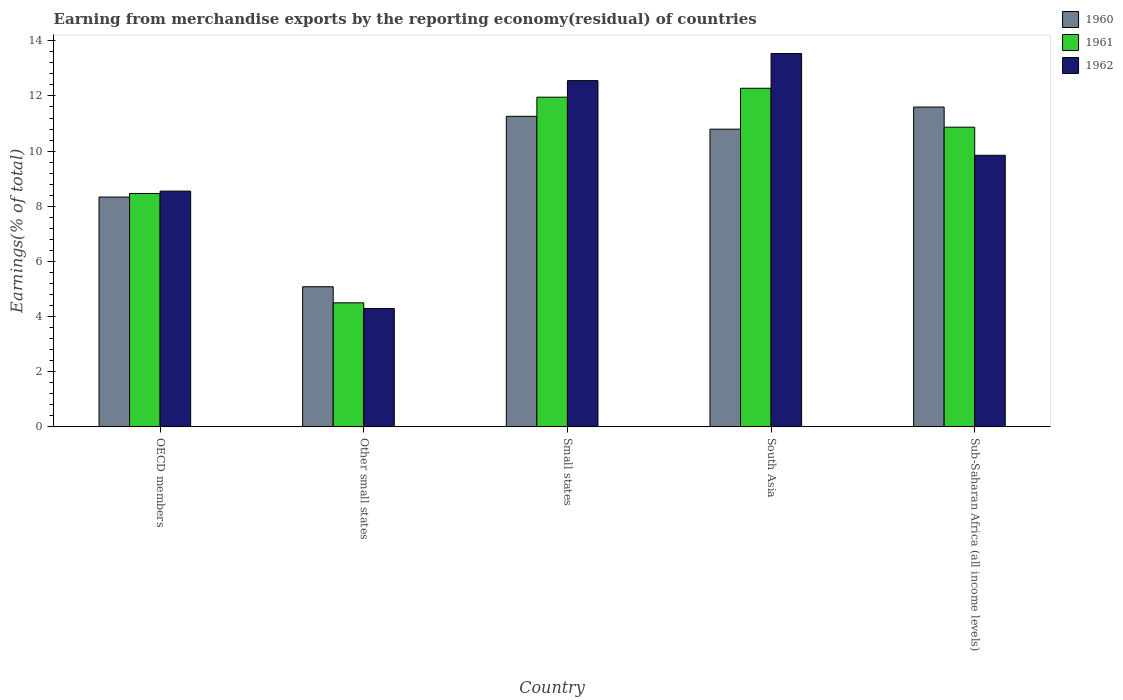How many different coloured bars are there?
Provide a short and direct response. 3. How many groups of bars are there?
Ensure brevity in your answer.  5. How many bars are there on the 3rd tick from the left?
Provide a short and direct response. 3. What is the label of the 2nd group of bars from the left?
Provide a succinct answer. Other small states. In how many cases, is the number of bars for a given country not equal to the number of legend labels?
Offer a terse response. 0. What is the percentage of amount earned from merchandise exports in 1962 in Other small states?
Your answer should be compact. 4.29. Across all countries, what is the maximum percentage of amount earned from merchandise exports in 1961?
Ensure brevity in your answer.  12.28. Across all countries, what is the minimum percentage of amount earned from merchandise exports in 1962?
Give a very brief answer. 4.29. In which country was the percentage of amount earned from merchandise exports in 1960 minimum?
Your response must be concise. Other small states. What is the total percentage of amount earned from merchandise exports in 1961 in the graph?
Offer a very short reply. 48.06. What is the difference between the percentage of amount earned from merchandise exports in 1960 in OECD members and that in Other small states?
Ensure brevity in your answer.  3.25. What is the difference between the percentage of amount earned from merchandise exports in 1960 in Small states and the percentage of amount earned from merchandise exports in 1961 in Other small states?
Offer a terse response. 6.76. What is the average percentage of amount earned from merchandise exports in 1962 per country?
Ensure brevity in your answer.  9.76. What is the difference between the percentage of amount earned from merchandise exports of/in 1960 and percentage of amount earned from merchandise exports of/in 1961 in Sub-Saharan Africa (all income levels)?
Give a very brief answer. 0.73. What is the ratio of the percentage of amount earned from merchandise exports in 1960 in Small states to that in South Asia?
Make the answer very short. 1.04. What is the difference between the highest and the second highest percentage of amount earned from merchandise exports in 1960?
Offer a very short reply. 0.47. What is the difference between the highest and the lowest percentage of amount earned from merchandise exports in 1960?
Your response must be concise. 6.52. Is the sum of the percentage of amount earned from merchandise exports in 1962 in OECD members and Other small states greater than the maximum percentage of amount earned from merchandise exports in 1961 across all countries?
Provide a short and direct response. Yes. What does the 3rd bar from the right in Other small states represents?
Your answer should be very brief. 1960. How many countries are there in the graph?
Provide a short and direct response. 5. How many legend labels are there?
Offer a very short reply. 3. What is the title of the graph?
Your response must be concise. Earning from merchandise exports by the reporting economy(residual) of countries. Does "1991" appear as one of the legend labels in the graph?
Offer a terse response. No. What is the label or title of the X-axis?
Your response must be concise. Country. What is the label or title of the Y-axis?
Provide a short and direct response. Earnings(% of total). What is the Earnings(% of total) of 1960 in OECD members?
Ensure brevity in your answer.  8.33. What is the Earnings(% of total) of 1961 in OECD members?
Your response must be concise. 8.46. What is the Earnings(% of total) of 1962 in OECD members?
Make the answer very short. 8.55. What is the Earnings(% of total) in 1960 in Other small states?
Offer a very short reply. 5.08. What is the Earnings(% of total) in 1961 in Other small states?
Provide a short and direct response. 4.5. What is the Earnings(% of total) in 1962 in Other small states?
Give a very brief answer. 4.29. What is the Earnings(% of total) in 1960 in Small states?
Make the answer very short. 11.26. What is the Earnings(% of total) of 1961 in Small states?
Ensure brevity in your answer.  11.96. What is the Earnings(% of total) in 1962 in Small states?
Provide a short and direct response. 12.56. What is the Earnings(% of total) of 1960 in South Asia?
Provide a succinct answer. 10.8. What is the Earnings(% of total) of 1961 in South Asia?
Ensure brevity in your answer.  12.28. What is the Earnings(% of total) in 1962 in South Asia?
Give a very brief answer. 13.54. What is the Earnings(% of total) of 1960 in Sub-Saharan Africa (all income levels)?
Give a very brief answer. 11.6. What is the Earnings(% of total) in 1961 in Sub-Saharan Africa (all income levels)?
Offer a very short reply. 10.87. What is the Earnings(% of total) in 1962 in Sub-Saharan Africa (all income levels)?
Provide a succinct answer. 9.85. Across all countries, what is the maximum Earnings(% of total) of 1960?
Ensure brevity in your answer.  11.6. Across all countries, what is the maximum Earnings(% of total) in 1961?
Give a very brief answer. 12.28. Across all countries, what is the maximum Earnings(% of total) of 1962?
Provide a short and direct response. 13.54. Across all countries, what is the minimum Earnings(% of total) in 1960?
Give a very brief answer. 5.08. Across all countries, what is the minimum Earnings(% of total) of 1961?
Give a very brief answer. 4.5. Across all countries, what is the minimum Earnings(% of total) of 1962?
Make the answer very short. 4.29. What is the total Earnings(% of total) in 1960 in the graph?
Your answer should be compact. 47.07. What is the total Earnings(% of total) in 1961 in the graph?
Offer a very short reply. 48.06. What is the total Earnings(% of total) in 1962 in the graph?
Offer a terse response. 48.78. What is the difference between the Earnings(% of total) of 1960 in OECD members and that in Other small states?
Offer a very short reply. 3.25. What is the difference between the Earnings(% of total) in 1961 in OECD members and that in Other small states?
Make the answer very short. 3.96. What is the difference between the Earnings(% of total) in 1962 in OECD members and that in Other small states?
Provide a short and direct response. 4.26. What is the difference between the Earnings(% of total) of 1960 in OECD members and that in Small states?
Your response must be concise. -2.93. What is the difference between the Earnings(% of total) in 1961 in OECD members and that in Small states?
Give a very brief answer. -3.49. What is the difference between the Earnings(% of total) in 1962 in OECD members and that in Small states?
Your response must be concise. -4.01. What is the difference between the Earnings(% of total) of 1960 in OECD members and that in South Asia?
Keep it short and to the point. -2.46. What is the difference between the Earnings(% of total) of 1961 in OECD members and that in South Asia?
Provide a succinct answer. -3.82. What is the difference between the Earnings(% of total) in 1962 in OECD members and that in South Asia?
Your answer should be very brief. -4.99. What is the difference between the Earnings(% of total) of 1960 in OECD members and that in Sub-Saharan Africa (all income levels)?
Your answer should be very brief. -3.26. What is the difference between the Earnings(% of total) in 1961 in OECD members and that in Sub-Saharan Africa (all income levels)?
Ensure brevity in your answer.  -2.4. What is the difference between the Earnings(% of total) of 1962 in OECD members and that in Sub-Saharan Africa (all income levels)?
Provide a short and direct response. -1.3. What is the difference between the Earnings(% of total) of 1960 in Other small states and that in Small states?
Make the answer very short. -6.18. What is the difference between the Earnings(% of total) of 1961 in Other small states and that in Small states?
Your response must be concise. -7.46. What is the difference between the Earnings(% of total) in 1962 in Other small states and that in Small states?
Your answer should be very brief. -8.26. What is the difference between the Earnings(% of total) in 1960 in Other small states and that in South Asia?
Provide a short and direct response. -5.71. What is the difference between the Earnings(% of total) in 1961 in Other small states and that in South Asia?
Provide a succinct answer. -7.78. What is the difference between the Earnings(% of total) in 1962 in Other small states and that in South Asia?
Your response must be concise. -9.24. What is the difference between the Earnings(% of total) of 1960 in Other small states and that in Sub-Saharan Africa (all income levels)?
Your response must be concise. -6.52. What is the difference between the Earnings(% of total) of 1961 in Other small states and that in Sub-Saharan Africa (all income levels)?
Your response must be concise. -6.37. What is the difference between the Earnings(% of total) of 1962 in Other small states and that in Sub-Saharan Africa (all income levels)?
Offer a very short reply. -5.56. What is the difference between the Earnings(% of total) in 1960 in Small states and that in South Asia?
Offer a very short reply. 0.47. What is the difference between the Earnings(% of total) of 1961 in Small states and that in South Asia?
Keep it short and to the point. -0.32. What is the difference between the Earnings(% of total) of 1962 in Small states and that in South Asia?
Your answer should be compact. -0.98. What is the difference between the Earnings(% of total) of 1960 in Small states and that in Sub-Saharan Africa (all income levels)?
Provide a succinct answer. -0.34. What is the difference between the Earnings(% of total) of 1961 in Small states and that in Sub-Saharan Africa (all income levels)?
Your response must be concise. 1.09. What is the difference between the Earnings(% of total) of 1962 in Small states and that in Sub-Saharan Africa (all income levels)?
Offer a terse response. 2.71. What is the difference between the Earnings(% of total) of 1960 in South Asia and that in Sub-Saharan Africa (all income levels)?
Make the answer very short. -0.8. What is the difference between the Earnings(% of total) in 1961 in South Asia and that in Sub-Saharan Africa (all income levels)?
Offer a very short reply. 1.41. What is the difference between the Earnings(% of total) in 1962 in South Asia and that in Sub-Saharan Africa (all income levels)?
Provide a short and direct response. 3.69. What is the difference between the Earnings(% of total) of 1960 in OECD members and the Earnings(% of total) of 1961 in Other small states?
Offer a very short reply. 3.84. What is the difference between the Earnings(% of total) of 1960 in OECD members and the Earnings(% of total) of 1962 in Other small states?
Make the answer very short. 4.04. What is the difference between the Earnings(% of total) in 1961 in OECD members and the Earnings(% of total) in 1962 in Other small states?
Your answer should be compact. 4.17. What is the difference between the Earnings(% of total) of 1960 in OECD members and the Earnings(% of total) of 1961 in Small states?
Provide a short and direct response. -3.62. What is the difference between the Earnings(% of total) of 1960 in OECD members and the Earnings(% of total) of 1962 in Small states?
Ensure brevity in your answer.  -4.22. What is the difference between the Earnings(% of total) in 1961 in OECD members and the Earnings(% of total) in 1962 in Small states?
Keep it short and to the point. -4.09. What is the difference between the Earnings(% of total) of 1960 in OECD members and the Earnings(% of total) of 1961 in South Asia?
Give a very brief answer. -3.94. What is the difference between the Earnings(% of total) in 1960 in OECD members and the Earnings(% of total) in 1962 in South Asia?
Your response must be concise. -5.2. What is the difference between the Earnings(% of total) of 1961 in OECD members and the Earnings(% of total) of 1962 in South Asia?
Ensure brevity in your answer.  -5.07. What is the difference between the Earnings(% of total) in 1960 in OECD members and the Earnings(% of total) in 1961 in Sub-Saharan Africa (all income levels)?
Give a very brief answer. -2.53. What is the difference between the Earnings(% of total) in 1960 in OECD members and the Earnings(% of total) in 1962 in Sub-Saharan Africa (all income levels)?
Make the answer very short. -1.51. What is the difference between the Earnings(% of total) of 1961 in OECD members and the Earnings(% of total) of 1962 in Sub-Saharan Africa (all income levels)?
Provide a short and direct response. -1.39. What is the difference between the Earnings(% of total) in 1960 in Other small states and the Earnings(% of total) in 1961 in Small states?
Your response must be concise. -6.87. What is the difference between the Earnings(% of total) in 1960 in Other small states and the Earnings(% of total) in 1962 in Small states?
Provide a short and direct response. -7.47. What is the difference between the Earnings(% of total) in 1961 in Other small states and the Earnings(% of total) in 1962 in Small states?
Keep it short and to the point. -8.06. What is the difference between the Earnings(% of total) of 1960 in Other small states and the Earnings(% of total) of 1961 in South Asia?
Offer a terse response. -7.2. What is the difference between the Earnings(% of total) of 1960 in Other small states and the Earnings(% of total) of 1962 in South Asia?
Provide a short and direct response. -8.46. What is the difference between the Earnings(% of total) in 1961 in Other small states and the Earnings(% of total) in 1962 in South Asia?
Your answer should be compact. -9.04. What is the difference between the Earnings(% of total) of 1960 in Other small states and the Earnings(% of total) of 1961 in Sub-Saharan Africa (all income levels)?
Offer a very short reply. -5.79. What is the difference between the Earnings(% of total) in 1960 in Other small states and the Earnings(% of total) in 1962 in Sub-Saharan Africa (all income levels)?
Keep it short and to the point. -4.77. What is the difference between the Earnings(% of total) of 1961 in Other small states and the Earnings(% of total) of 1962 in Sub-Saharan Africa (all income levels)?
Your response must be concise. -5.35. What is the difference between the Earnings(% of total) of 1960 in Small states and the Earnings(% of total) of 1961 in South Asia?
Your answer should be compact. -1.02. What is the difference between the Earnings(% of total) of 1960 in Small states and the Earnings(% of total) of 1962 in South Asia?
Your answer should be compact. -2.28. What is the difference between the Earnings(% of total) of 1961 in Small states and the Earnings(% of total) of 1962 in South Asia?
Keep it short and to the point. -1.58. What is the difference between the Earnings(% of total) of 1960 in Small states and the Earnings(% of total) of 1961 in Sub-Saharan Africa (all income levels)?
Offer a very short reply. 0.39. What is the difference between the Earnings(% of total) in 1960 in Small states and the Earnings(% of total) in 1962 in Sub-Saharan Africa (all income levels)?
Make the answer very short. 1.41. What is the difference between the Earnings(% of total) in 1961 in Small states and the Earnings(% of total) in 1962 in Sub-Saharan Africa (all income levels)?
Offer a very short reply. 2.11. What is the difference between the Earnings(% of total) in 1960 in South Asia and the Earnings(% of total) in 1961 in Sub-Saharan Africa (all income levels)?
Your response must be concise. -0.07. What is the difference between the Earnings(% of total) of 1960 in South Asia and the Earnings(% of total) of 1962 in Sub-Saharan Africa (all income levels)?
Offer a very short reply. 0.95. What is the difference between the Earnings(% of total) of 1961 in South Asia and the Earnings(% of total) of 1962 in Sub-Saharan Africa (all income levels)?
Keep it short and to the point. 2.43. What is the average Earnings(% of total) in 1960 per country?
Keep it short and to the point. 9.41. What is the average Earnings(% of total) in 1961 per country?
Your answer should be compact. 9.61. What is the average Earnings(% of total) in 1962 per country?
Provide a short and direct response. 9.76. What is the difference between the Earnings(% of total) of 1960 and Earnings(% of total) of 1961 in OECD members?
Your answer should be very brief. -0.13. What is the difference between the Earnings(% of total) in 1960 and Earnings(% of total) in 1962 in OECD members?
Provide a short and direct response. -0.21. What is the difference between the Earnings(% of total) in 1961 and Earnings(% of total) in 1962 in OECD members?
Keep it short and to the point. -0.09. What is the difference between the Earnings(% of total) of 1960 and Earnings(% of total) of 1961 in Other small states?
Make the answer very short. 0.58. What is the difference between the Earnings(% of total) of 1960 and Earnings(% of total) of 1962 in Other small states?
Your answer should be very brief. 0.79. What is the difference between the Earnings(% of total) of 1961 and Earnings(% of total) of 1962 in Other small states?
Keep it short and to the point. 0.21. What is the difference between the Earnings(% of total) of 1960 and Earnings(% of total) of 1961 in Small states?
Offer a terse response. -0.69. What is the difference between the Earnings(% of total) of 1960 and Earnings(% of total) of 1962 in Small states?
Provide a succinct answer. -1.29. What is the difference between the Earnings(% of total) of 1961 and Earnings(% of total) of 1962 in Small states?
Your response must be concise. -0.6. What is the difference between the Earnings(% of total) of 1960 and Earnings(% of total) of 1961 in South Asia?
Ensure brevity in your answer.  -1.48. What is the difference between the Earnings(% of total) of 1960 and Earnings(% of total) of 1962 in South Asia?
Make the answer very short. -2.74. What is the difference between the Earnings(% of total) of 1961 and Earnings(% of total) of 1962 in South Asia?
Offer a terse response. -1.26. What is the difference between the Earnings(% of total) of 1960 and Earnings(% of total) of 1961 in Sub-Saharan Africa (all income levels)?
Provide a short and direct response. 0.73. What is the difference between the Earnings(% of total) of 1960 and Earnings(% of total) of 1962 in Sub-Saharan Africa (all income levels)?
Provide a short and direct response. 1.75. What is the difference between the Earnings(% of total) of 1961 and Earnings(% of total) of 1962 in Sub-Saharan Africa (all income levels)?
Your answer should be compact. 1.02. What is the ratio of the Earnings(% of total) of 1960 in OECD members to that in Other small states?
Your answer should be compact. 1.64. What is the ratio of the Earnings(% of total) in 1961 in OECD members to that in Other small states?
Provide a short and direct response. 1.88. What is the ratio of the Earnings(% of total) of 1962 in OECD members to that in Other small states?
Keep it short and to the point. 1.99. What is the ratio of the Earnings(% of total) of 1960 in OECD members to that in Small states?
Provide a succinct answer. 0.74. What is the ratio of the Earnings(% of total) of 1961 in OECD members to that in Small states?
Make the answer very short. 0.71. What is the ratio of the Earnings(% of total) in 1962 in OECD members to that in Small states?
Make the answer very short. 0.68. What is the ratio of the Earnings(% of total) in 1960 in OECD members to that in South Asia?
Your answer should be compact. 0.77. What is the ratio of the Earnings(% of total) in 1961 in OECD members to that in South Asia?
Ensure brevity in your answer.  0.69. What is the ratio of the Earnings(% of total) of 1962 in OECD members to that in South Asia?
Your response must be concise. 0.63. What is the ratio of the Earnings(% of total) in 1960 in OECD members to that in Sub-Saharan Africa (all income levels)?
Provide a succinct answer. 0.72. What is the ratio of the Earnings(% of total) of 1961 in OECD members to that in Sub-Saharan Africa (all income levels)?
Provide a short and direct response. 0.78. What is the ratio of the Earnings(% of total) of 1962 in OECD members to that in Sub-Saharan Africa (all income levels)?
Your response must be concise. 0.87. What is the ratio of the Earnings(% of total) in 1960 in Other small states to that in Small states?
Offer a terse response. 0.45. What is the ratio of the Earnings(% of total) of 1961 in Other small states to that in Small states?
Your answer should be very brief. 0.38. What is the ratio of the Earnings(% of total) of 1962 in Other small states to that in Small states?
Keep it short and to the point. 0.34. What is the ratio of the Earnings(% of total) of 1960 in Other small states to that in South Asia?
Your answer should be very brief. 0.47. What is the ratio of the Earnings(% of total) of 1961 in Other small states to that in South Asia?
Offer a very short reply. 0.37. What is the ratio of the Earnings(% of total) in 1962 in Other small states to that in South Asia?
Provide a succinct answer. 0.32. What is the ratio of the Earnings(% of total) in 1960 in Other small states to that in Sub-Saharan Africa (all income levels)?
Make the answer very short. 0.44. What is the ratio of the Earnings(% of total) of 1961 in Other small states to that in Sub-Saharan Africa (all income levels)?
Make the answer very short. 0.41. What is the ratio of the Earnings(% of total) in 1962 in Other small states to that in Sub-Saharan Africa (all income levels)?
Keep it short and to the point. 0.44. What is the ratio of the Earnings(% of total) in 1960 in Small states to that in South Asia?
Make the answer very short. 1.04. What is the ratio of the Earnings(% of total) in 1961 in Small states to that in South Asia?
Offer a very short reply. 0.97. What is the ratio of the Earnings(% of total) of 1962 in Small states to that in South Asia?
Provide a short and direct response. 0.93. What is the ratio of the Earnings(% of total) of 1960 in Small states to that in Sub-Saharan Africa (all income levels)?
Provide a short and direct response. 0.97. What is the ratio of the Earnings(% of total) of 1961 in Small states to that in Sub-Saharan Africa (all income levels)?
Provide a succinct answer. 1.1. What is the ratio of the Earnings(% of total) in 1962 in Small states to that in Sub-Saharan Africa (all income levels)?
Provide a short and direct response. 1.27. What is the ratio of the Earnings(% of total) of 1960 in South Asia to that in Sub-Saharan Africa (all income levels)?
Your response must be concise. 0.93. What is the ratio of the Earnings(% of total) in 1961 in South Asia to that in Sub-Saharan Africa (all income levels)?
Ensure brevity in your answer.  1.13. What is the ratio of the Earnings(% of total) in 1962 in South Asia to that in Sub-Saharan Africa (all income levels)?
Your answer should be compact. 1.37. What is the difference between the highest and the second highest Earnings(% of total) in 1960?
Your response must be concise. 0.34. What is the difference between the highest and the second highest Earnings(% of total) of 1961?
Give a very brief answer. 0.32. What is the difference between the highest and the second highest Earnings(% of total) of 1962?
Keep it short and to the point. 0.98. What is the difference between the highest and the lowest Earnings(% of total) of 1960?
Offer a terse response. 6.52. What is the difference between the highest and the lowest Earnings(% of total) of 1961?
Offer a terse response. 7.78. What is the difference between the highest and the lowest Earnings(% of total) in 1962?
Provide a short and direct response. 9.24. 